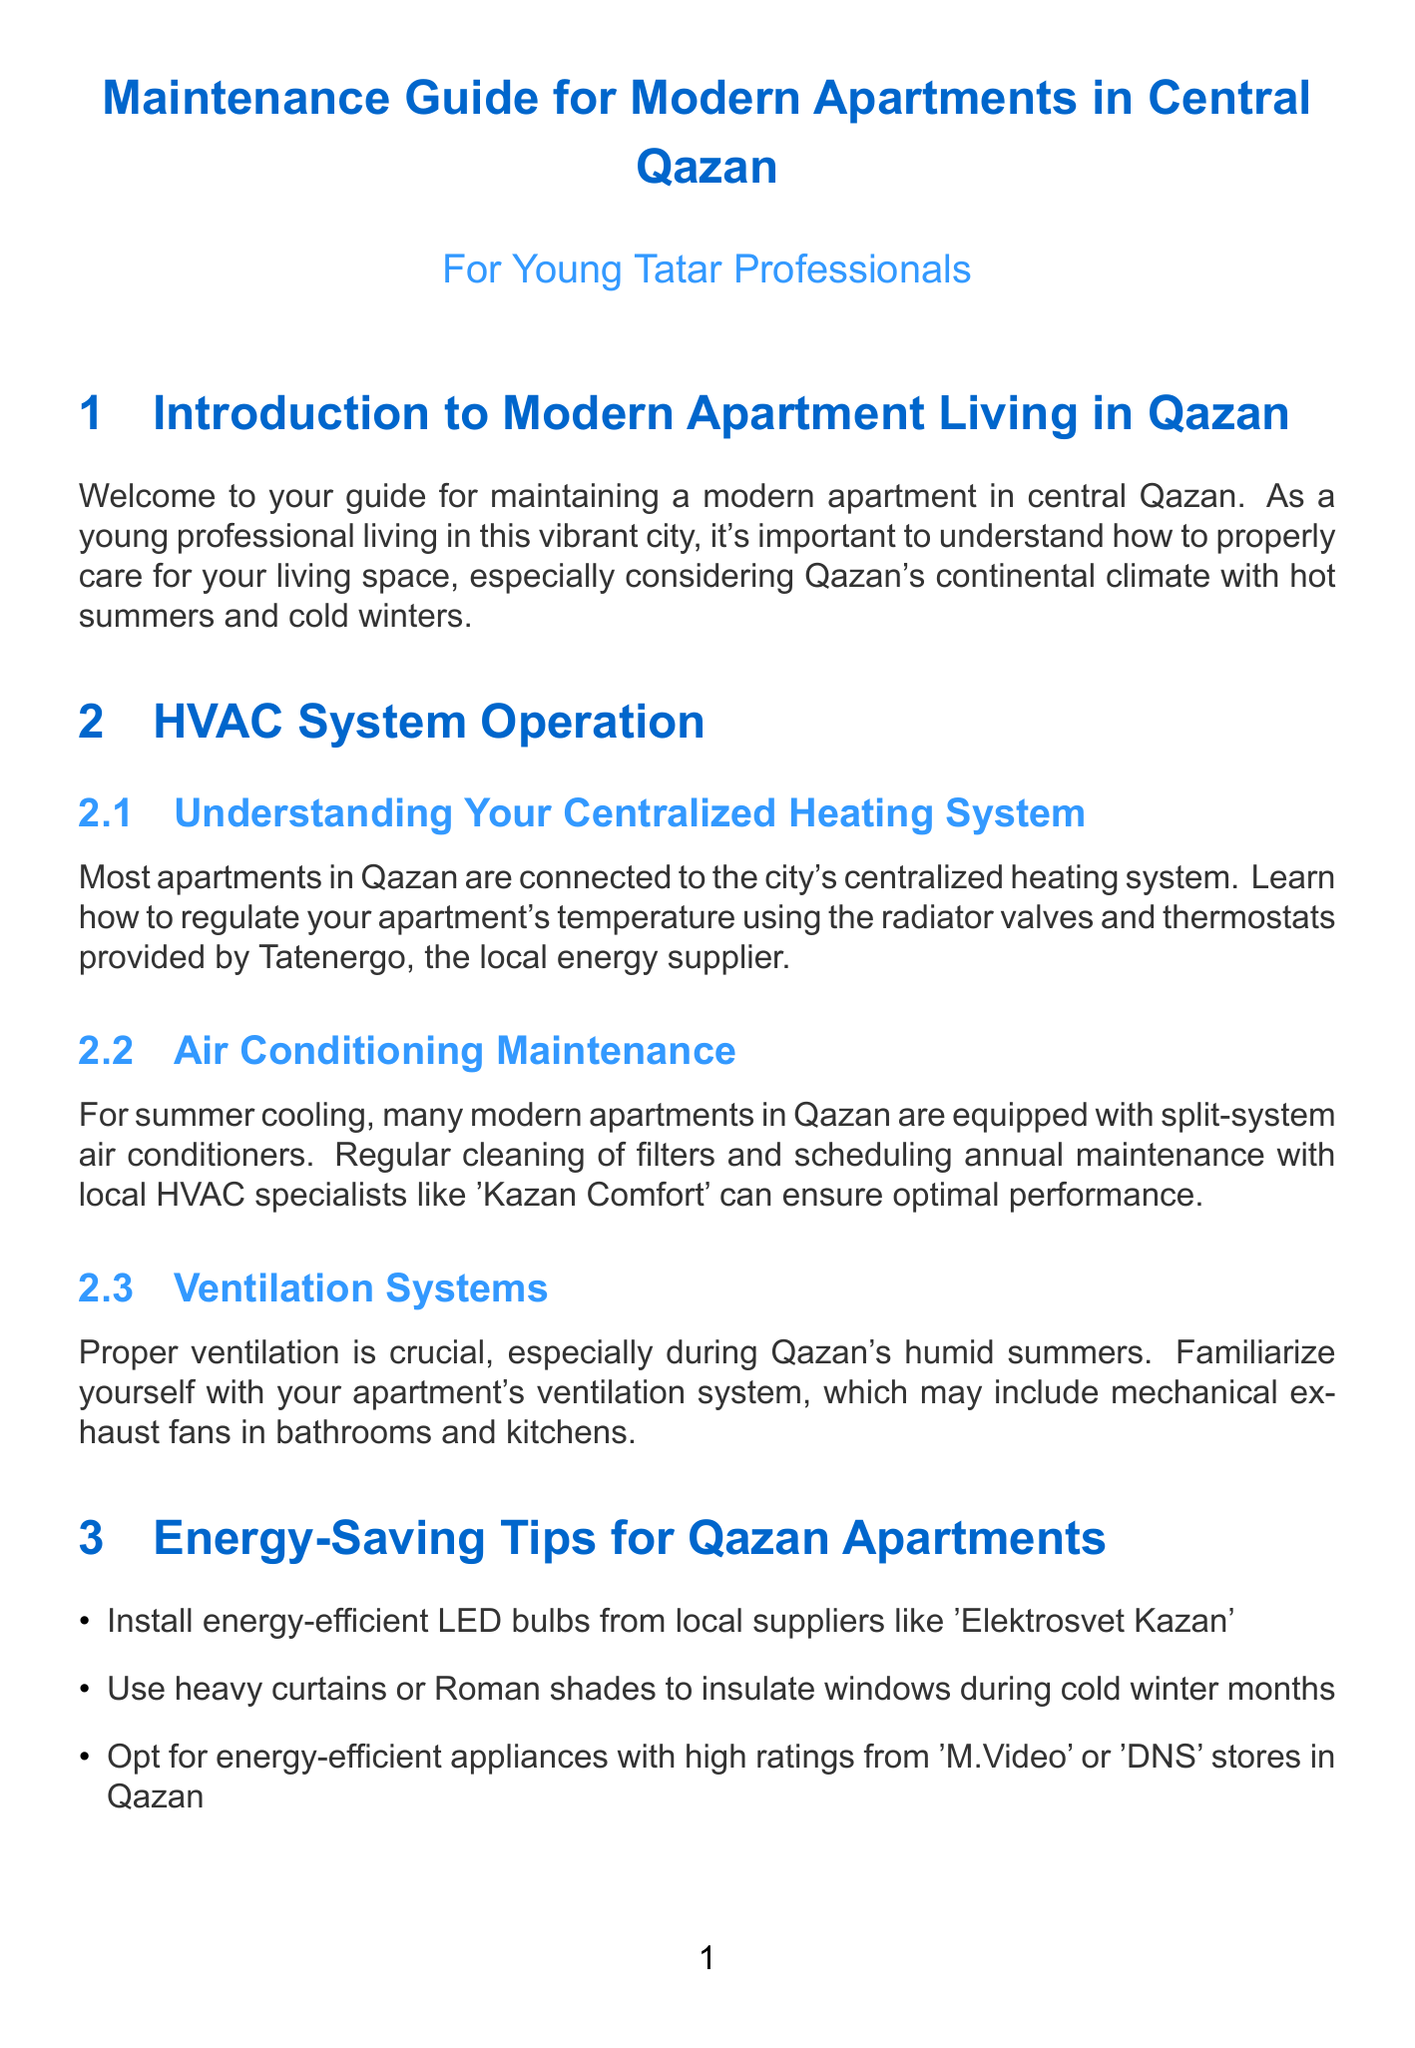What is the name of the local energy supplier? The document specifies that the local energy supplier is Tatenergo, which is mentioned in the HVAC System Operation section.
Answer: Tatenergo What should you use to insulate windows in winter? The document suggests using heavy curtains or Roman shades during cold winter months as an energy-saving tip.
Answer: Heavy curtains or Roman shades Who supplies the water in Qazan? The document states that Qazan's water is supplied by Vodokanal Kazan, provided in the Water System Maintenance section.
Answer: Vodokanal Kazan Which company should be contacted for HVAC maintenance? The document recommends contacting Kazan Comfort for annual air conditioning maintenance in the HVAC System Operation section.
Answer: Kazan Comfort What is the recommended action for balcony upkeep? The document advises regularly cleaning the drainage system of balconies to prevent water accumulation.
Answer: Clean the drainage system How many energy-saving tips are listed for Qazan apartments? The document lists five energy-saving tips in the Energy-Saving Tips for Qazan Apartments section.
Answer: Five What type of flooring care product is suggested? The document recommends using appropriate cleaning products available at Leroy Merlin Kazan for flooring care.
Answer: Leroy Merlin Kazan What community platform is mentioned for building connection? The document mentions joining the community group organized through VKontakte as a way of engaging with neighbors.
Answer: VKontakte What is important about mechanical exhaust fans? The document highlights the importance of proper ventilation, stating that mechanical exhaust fans might be included in your apartment's ventilation system.
Answer: Proper ventilation 